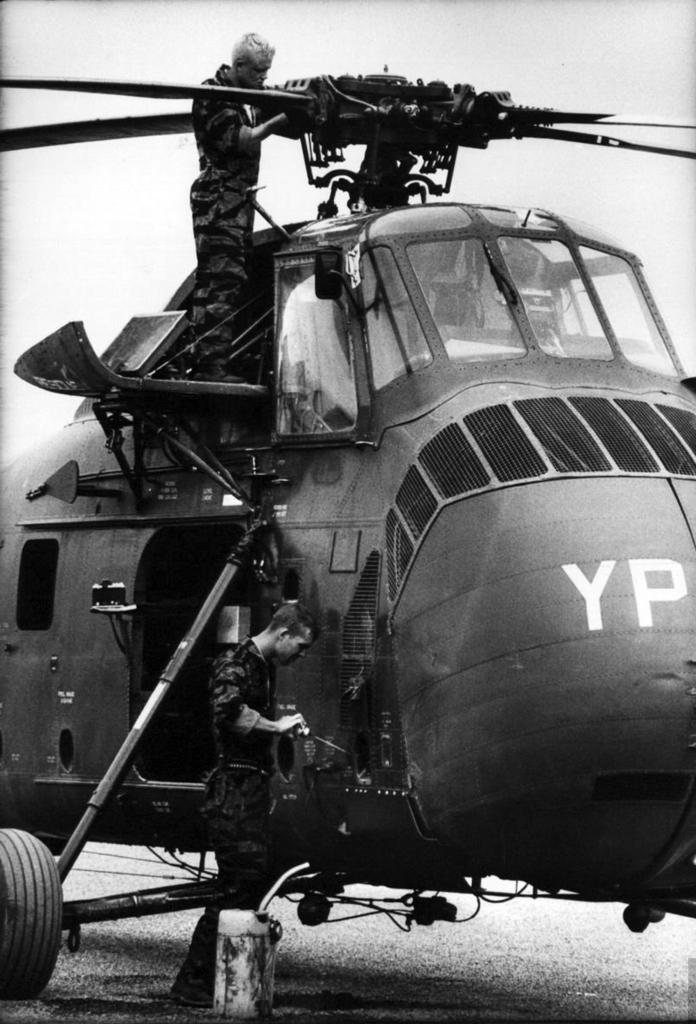<image>
Offer a succinct explanation of the picture presented. A helicopter with the lets YP on it is being worked on by an army repairman. 